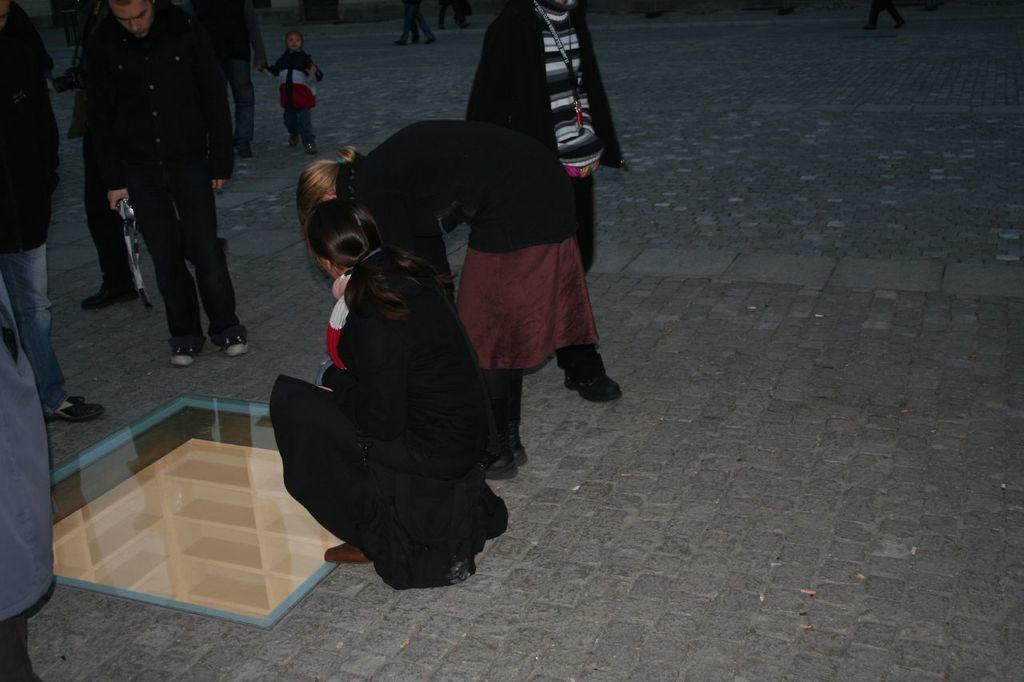How many people are in the image? There is a group of people standing in the image. What is the position of one of the people in the image? There is a person in a squat position in the image. Can you describe the setting of the image? The setting appears to be an underground cabin. How many leaves are on the birthday cake in the image? There is no birthday cake or leaves present in the image. What type of frogs can be seen in the image? There are no frogs present in the image. 